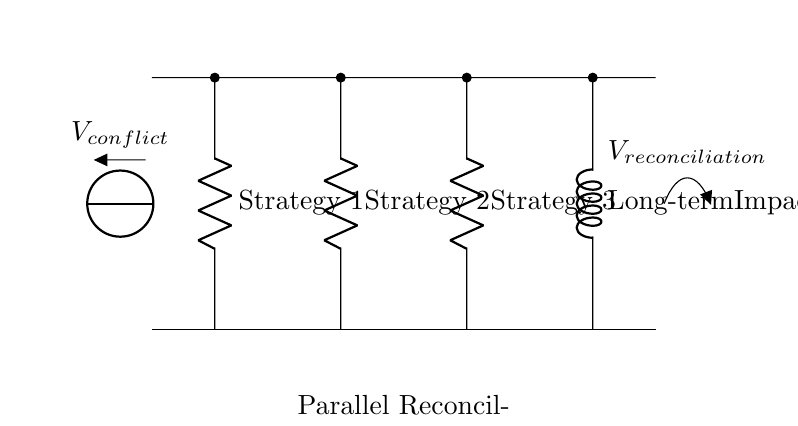What are the components in the circuit? The circuit includes three resistors (R1, R2, R3) and one inductor (L) which are components used to illustrate different reconciliation strategies and their long-term impact.
Answer: R1, R2, R3, L What does R1 represent? R1 is labeled as “Strategy 1,” indicating one of the parallel reconciliation strategies employed in the network.
Answer: Strategy 1 How many parallel strategies are depicted in the diagram? The circuit shows three resistors as parallel strategies (R1, R2, R3) in addition to the inductor, making four strategies in total.
Answer: Four What does the inductor symbolize in this context? The inductor (L) is labeled as “Long-term Impact,” representing the lasting effects of the reconciliation strategies over time.
Answer: Long-term Impact How does the voltage across the resistors compare to that across the inductor? All components are in parallel, meaning they share the same voltage, which is equal to the voltage of the conflict supply.
Answer: Equal What is the significance of the voltage labeled as V_conflict? V_conflict is the source voltage representing the initial conditions of the conflict, which drives the reconciliation strategies represented by the parallel circuit components.
Answer: Initial conflict voltage What happens to the overall current if one strategy (resistor) fails? If one resistor fails, the total current in the circuit may still be sustained by the remaining resistors, demonstrating resilience in reconciliation efforts.
Answer: Resilience maintained 